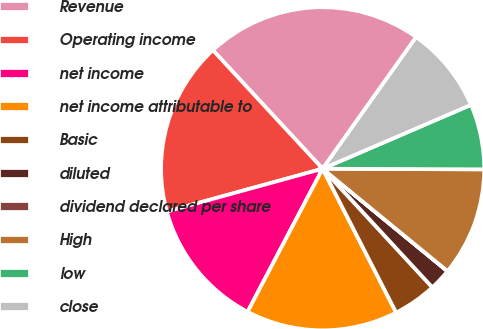Convert chart. <chart><loc_0><loc_0><loc_500><loc_500><pie_chart><fcel>Revenue<fcel>Operating income<fcel>net income<fcel>net income attributable to<fcel>Basic<fcel>diluted<fcel>dividend declared per share<fcel>High<fcel>low<fcel>close<nl><fcel>21.72%<fcel>17.38%<fcel>13.04%<fcel>15.21%<fcel>4.36%<fcel>2.18%<fcel>0.01%<fcel>10.87%<fcel>6.53%<fcel>8.7%<nl></chart> 